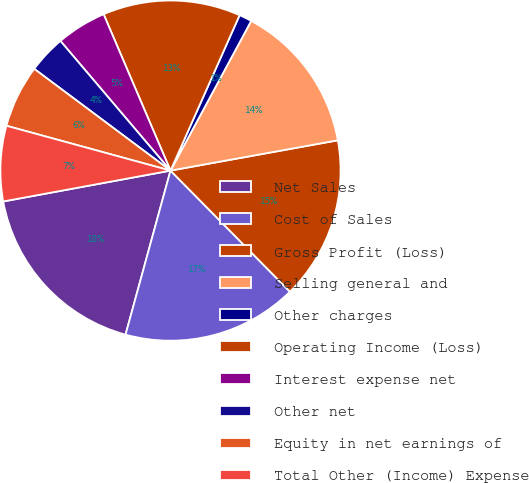<chart> <loc_0><loc_0><loc_500><loc_500><pie_chart><fcel>Net Sales<fcel>Cost of Sales<fcel>Gross Profit (Loss)<fcel>Selling general and<fcel>Other charges<fcel>Operating Income (Loss)<fcel>Interest expense net<fcel>Other net<fcel>Equity in net earnings of<fcel>Total Other (Income) Expense<nl><fcel>17.84%<fcel>16.65%<fcel>15.46%<fcel>14.28%<fcel>1.21%<fcel>13.09%<fcel>4.77%<fcel>3.59%<fcel>5.96%<fcel>7.15%<nl></chart> 